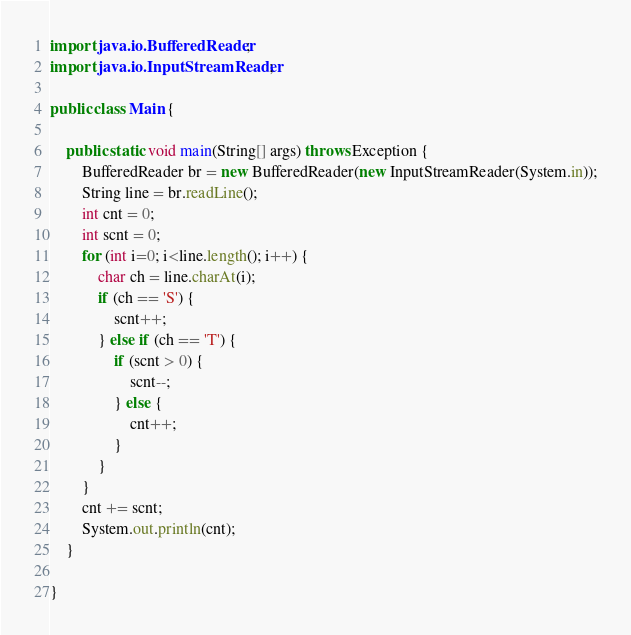Convert code to text. <code><loc_0><loc_0><loc_500><loc_500><_Java_>import java.io.BufferedReader;
import java.io.InputStreamReader;

public class Main {

	public static void main(String[] args) throws Exception {
		BufferedReader br = new BufferedReader(new InputStreamReader(System.in));
		String line = br.readLine();
		int cnt = 0;
		int scnt = 0;
		for (int i=0; i<line.length(); i++) {
			char ch = line.charAt(i);
			if (ch == 'S') {
				scnt++;
			} else if (ch == 'T') {
				if (scnt > 0) {
					scnt--;
				} else {
					cnt++;
				}
			}
		}
		cnt += scnt;
		System.out.println(cnt);
	}

}
</code> 